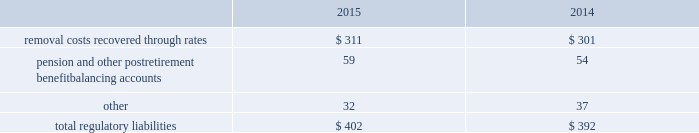The authorized costs of $ 76 are to be recovered via a surcharge over a twenty-year period beginning october 2012 .
Surcharges collected as of december 31 , 2015 and 2014 were $ 4 and $ 5 , respectively .
In addition to the authorized costs , the company expects to incur additional costs totaling $ 34 , which will be recovered from contributions made by the california state coastal conservancy .
Contributions collected as of december 31 , 2015 and 2014 were $ 8 and $ 5 , respectively .
Regulatory balancing accounts accumulate differences between revenues recognized and authorized revenue requirements until they are collected from customers or are refunded .
Regulatory balancing accounts include low income programs and purchased power and water accounts .
Debt expense is amortized over the lives of the respective issues .
Call premiums on the redemption of long- term debt , as well as unamortized debt expense , are deferred and amortized to the extent they will be recovered through future service rates .
Purchase premium recoverable through rates is primarily the recovery of the acquisition premiums related to an asset acquisition by the company 2019s california subsidiary during 2002 , and acquisitions in 2007 by the company 2019s new jersey subsidiary .
As authorized for recovery by the california and new jersey pucs , these costs are being amortized to depreciation and amortization in the consolidated statements of operations through november 2048 .
Tank painting costs are generally deferred and amortized to operations and maintenance expense in the consolidated statements of operations on a straight-line basis over periods ranging from five to fifteen years , as authorized by the regulatory authorities in their determination of rates charged for service .
Other regulatory assets include certain deferred business transformation costs , construction costs for treatment facilities , property tax stabilization , employee-related costs , business services project expenses , coastal water project costs , rate case expenditures and environmental remediation costs among others .
These costs are deferred because the amounts are being recovered in rates or are probable of recovery through rates in future periods .
Regulatory liabilities the regulatory liabilities generally represent probable future reductions in revenues associated with amounts that are to be credited or refunded to customers through the rate-making process .
The table summarizes the composition of regulatory liabilities as of december 31: .
Removal costs recovered through rates are estimated costs to retire assets at the end of their expected useful life that are recovered through customer rates over the life of the associated assets .
In december 2008 , the company 2019s subsidiary in new jersey , at the direction of the new jersey puc , began to depreciate $ 48 of the total balance into depreciation and amortization expense in the consolidated statements of operations via straight line amortization through november 2048 .
Pension and other postretirement benefit balancing accounts represent the difference between costs incurred and costs authorized by the puc 2019s that are expected to be refunded to customers. .
What were the removal costs as a percent of total regulatory costs in 2015? 
Rationale: 77.4% of the total regulatory costs were made of removal costs in 2015
Computations: (311 / 402)
Answer: 0.77363. The authorized costs of $ 76 are to be recovered via a surcharge over a twenty-year period beginning october 2012 .
Surcharges collected as of december 31 , 2015 and 2014 were $ 4 and $ 5 , respectively .
In addition to the authorized costs , the company expects to incur additional costs totaling $ 34 , which will be recovered from contributions made by the california state coastal conservancy .
Contributions collected as of december 31 , 2015 and 2014 were $ 8 and $ 5 , respectively .
Regulatory balancing accounts accumulate differences between revenues recognized and authorized revenue requirements until they are collected from customers or are refunded .
Regulatory balancing accounts include low income programs and purchased power and water accounts .
Debt expense is amortized over the lives of the respective issues .
Call premiums on the redemption of long- term debt , as well as unamortized debt expense , are deferred and amortized to the extent they will be recovered through future service rates .
Purchase premium recoverable through rates is primarily the recovery of the acquisition premiums related to an asset acquisition by the company 2019s california subsidiary during 2002 , and acquisitions in 2007 by the company 2019s new jersey subsidiary .
As authorized for recovery by the california and new jersey pucs , these costs are being amortized to depreciation and amortization in the consolidated statements of operations through november 2048 .
Tank painting costs are generally deferred and amortized to operations and maintenance expense in the consolidated statements of operations on a straight-line basis over periods ranging from five to fifteen years , as authorized by the regulatory authorities in their determination of rates charged for service .
Other regulatory assets include certain deferred business transformation costs , construction costs for treatment facilities , property tax stabilization , employee-related costs , business services project expenses , coastal water project costs , rate case expenditures and environmental remediation costs among others .
These costs are deferred because the amounts are being recovered in rates or are probable of recovery through rates in future periods .
Regulatory liabilities the regulatory liabilities generally represent probable future reductions in revenues associated with amounts that are to be credited or refunded to customers through the rate-making process .
The table summarizes the composition of regulatory liabilities as of december 31: .
Removal costs recovered through rates are estimated costs to retire assets at the end of their expected useful life that are recovered through customer rates over the life of the associated assets .
In december 2008 , the company 2019s subsidiary in new jersey , at the direction of the new jersey puc , began to depreciate $ 48 of the total balance into depreciation and amortization expense in the consolidated statements of operations via straight line amortization through november 2048 .
Pension and other postretirement benefit balancing accounts represent the difference between costs incurred and costs authorized by the puc 2019s that are expected to be refunded to customers. .
How much of the additional costs from the california state coastal conservancy is awk expected to collect in 2015? 
Computations: (8 / 34)
Answer: 0.23529. 